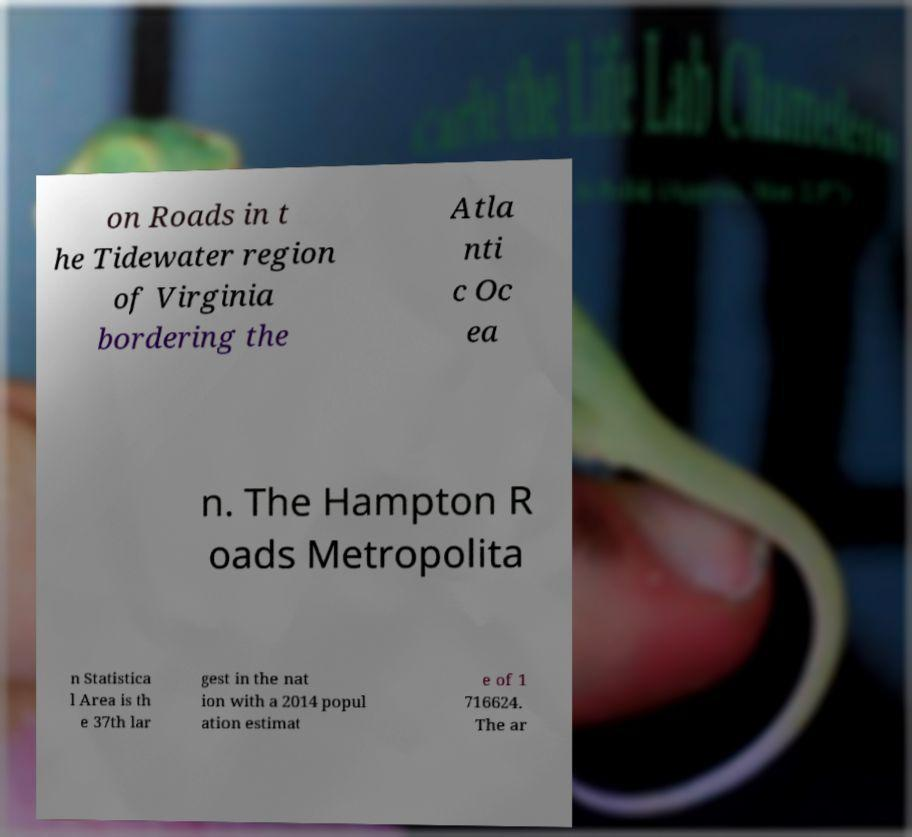There's text embedded in this image that I need extracted. Can you transcribe it verbatim? on Roads in t he Tidewater region of Virginia bordering the Atla nti c Oc ea n. The Hampton R oads Metropolita n Statistica l Area is th e 37th lar gest in the nat ion with a 2014 popul ation estimat e of 1 716624. The ar 